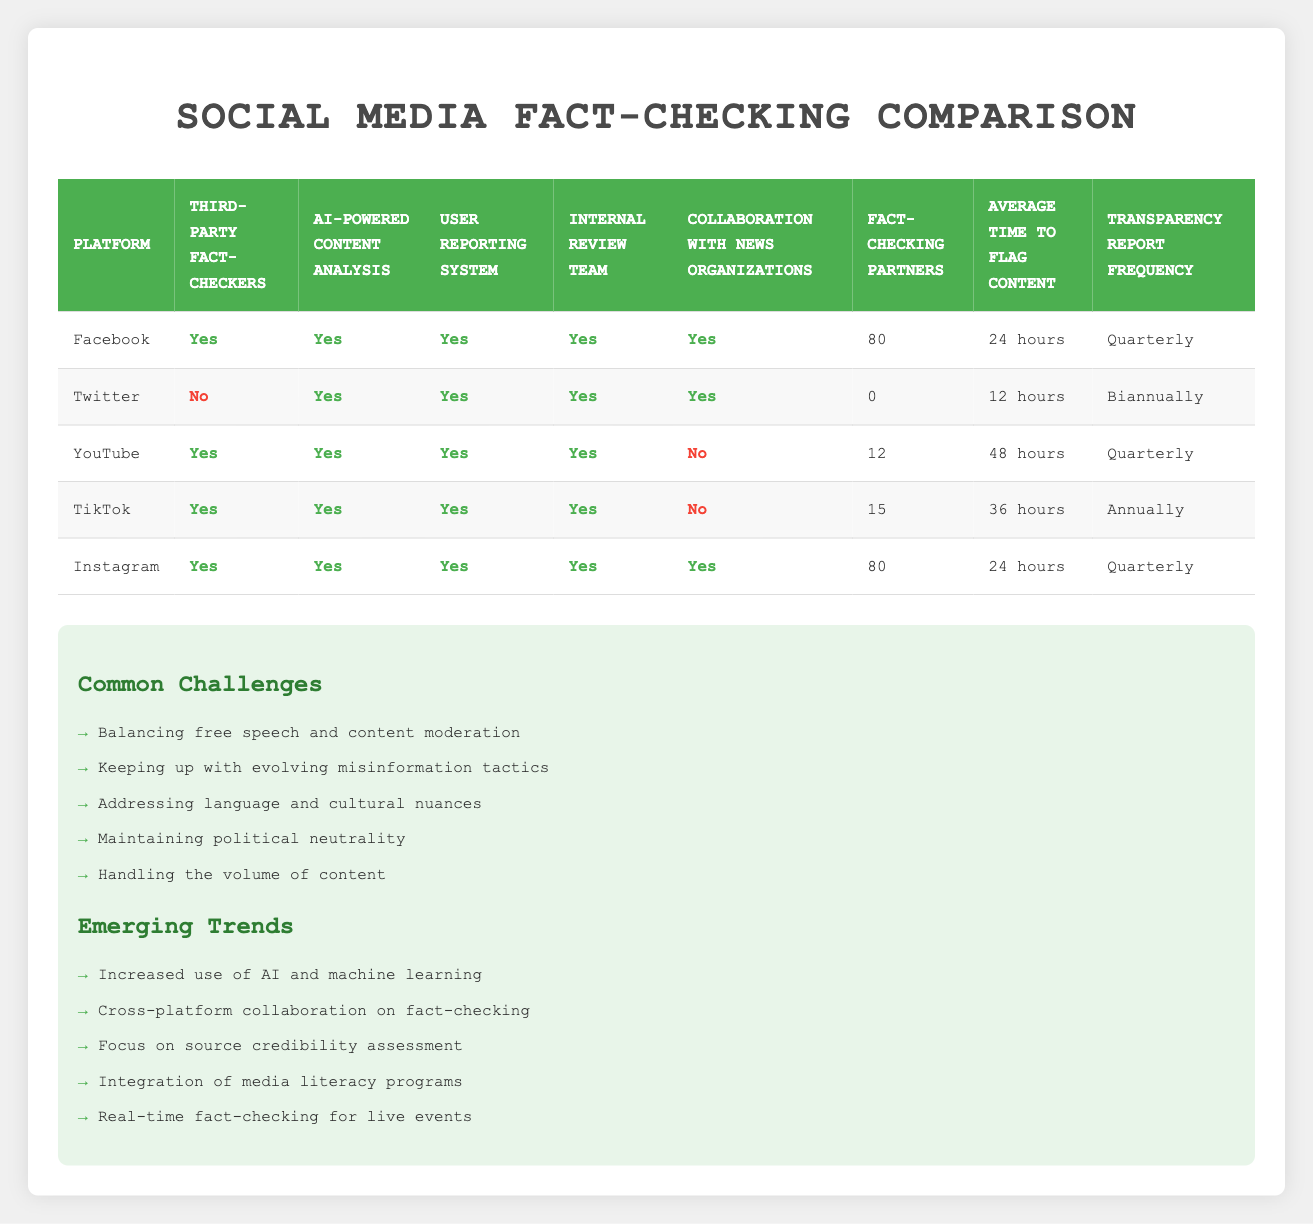What fact-checking methods are available for Facebook? From the table, we can see that Facebook uses third-party fact-checkers, AI-powered content analysis, user reporting systems, internal review teams, and collaborates with news organizations. All of these methods are listed as "Yes" in the respective columns for Facebook.
Answer: Third-party fact-checkers, AI-powered content analysis, user reporting, internal review teams, collaboration with news organizations Which platforms do not collaborate with news organizations? Looking at the collaboration with news organizations column, Instagram, Facebook, YouTube, and TikTok are marked "Yes," while Twitter and YouTube are marked "No." Thus, the platforms that do not collaborate with news organizations are Twitter and YouTube.
Answer: Twitter, YouTube How many fact-checking partners does YouTube have? The table indicates the number of fact-checking partners for YouTube in the specified column. It shows that YouTube has 12 fact-checking partners.
Answer: 12 What is the average time to flag content across all platforms? The average time to flag content can be calculated by converting the time into hours for each platform: Facebook (24), Twitter (12), YouTube (48), TikTok (36), and Instagram (24).  
Calculating the mean: (24 + 12 + 48 + 36 + 24) / 5 = 144 / 5 = 28.8 hours.
Answer: 28.8 hours Does Instagram use AI-powered content analysis? Referring to the table, the column for AI-powered content analysis shows "Yes" for Instagram. This indicates that Instagram employs this method.
Answer: Yes Which platform has the longest average time to flag content? By examining the "Average time to flag content" column, we can see that YouTube has the longest average time listed at 48 hours.
Answer: YouTube What percentage of platforms use third-party fact-checkers? The platforms that utilize third-party fact-checkers are Facebook, YouTube, TikTok, and Instagram, totaling four out of five platforms. To find the percentage, we calculate (4 / 5) * 100 = 80%.
Answer: 80% Which platform has the most fact-checking partners and how many do they have? The platforms listed with fact-checking partners are Facebook and Instagram, each with 80 partners. Therefore, both Facebook and Instagram tie for the most partners, having 80 each.
Answer: Facebook and Instagram; 80 partners each What is the frequency of transparency reports for TikTok? According to the table, TikTok's transparency report frequency is listed as "Annually."
Answer: Annually 